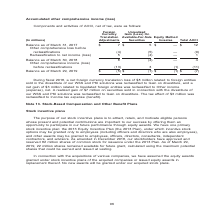According to Nortonlifelock's financial document, What does the table show? Components and activities of AOCI, net of tax,. The document states: "Components and activities of AOCI, net of tax, were as follows:..." Also, What units are used in the table? According to the financial document, millions. The relevant text states: "Translation Available-For-Sale Equity Method (In millions) Adjustments Securities Investee Total AOCI..." Also, What is the Total AOCI  Balance as of March 31, 2017? According to the financial document, $12 (in millions). The relevant text states: "Balance as of March 31, 2017 $ 7 $ 5 $ — $ 12 Other comprehensive loss before reclassifications (4) (5) — (9) Reclassification to net income (los..." Also, can you calculate: As of March 31, 2017, what is the difference between the value of foreign currency translation adjustments and the unrealized gain on available-for-sale securities?   Based on the calculation: 7-5, the result is 2 (in millions). This is based on the information: "Balance as of March 31, 2017 $ 7 $ 5 $ — $ 12 Other comprehensive loss before reclassifications (4) (5) — (9) Reclassification to ne Balance as of March 31, 2017 $ 7 $ 5 $ — $ 12 Other comprehensive l..." The key data points involved are: 5, 7. Also, can you calculate: What is the average balance as of the end of fiscal years 2017, 2018 and 2019 for Total AOCI? To answer this question, I need to perform calculations using the financial data. The calculation is: (12+4+(-7))/3, which equals 3 (in millions). This is based on the information: "Balance as of March 31, 2017 $ 7 $ 5 $ — $ 12 Other comprehensive loss before reclassifications (4) (5) — (9) Reclassification to net income (los Balance as of March 31, 2017 $ 7 $ 5 $ — $ 12 Other co..." The key data points involved are: 12, 4, 7. Also, can you calculate: What is the  Other comprehensive income (loss) before reclassifications expressed as a percentage of  Balance as of March 29, 2019 for total AOCI? To answer this question, I need to perform calculations using the financial data. The calculation is: -11/-7, which equals 157.14 (percentage). This is based on the information: "ncome (loss) before reclassifications (13) 3 (1) (11) Balance as of March 31, 2017 $ 7 $ 5 $ — $ 12 Other comprehensive loss before reclassifications (4) (5) — (9) Reclassification to ne..." The key data points involved are: 11. 